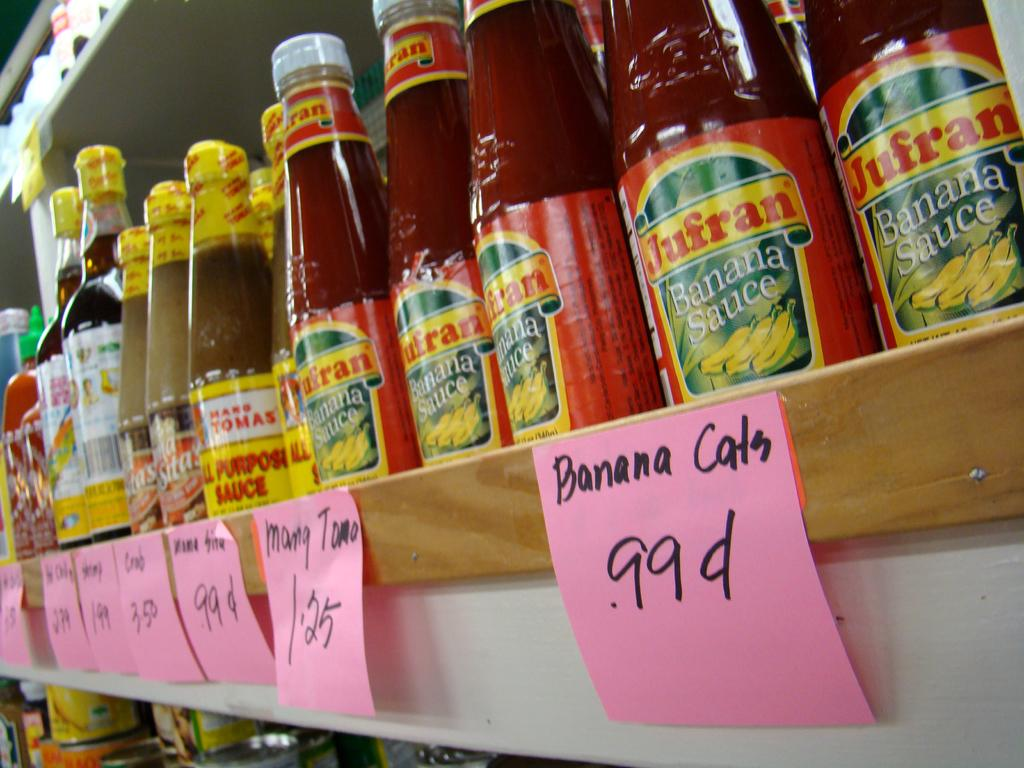Provide a one-sentence caption for the provided image. A shelf filled with Jufran Banana Sauce with pink post its with he words Banana cats .99 cents. 